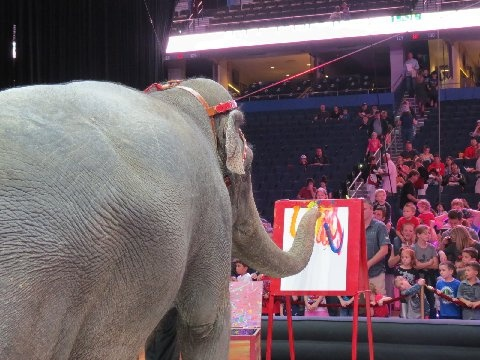Describe the objects in this image and their specific colors. I can see elephant in black, darkgray, gray, and lightgray tones, people in black, maroon, brown, and purple tones, people in black, purple, and brown tones, people in black, brown, gray, and maroon tones, and people in black, navy, brown, gray, and blue tones in this image. 